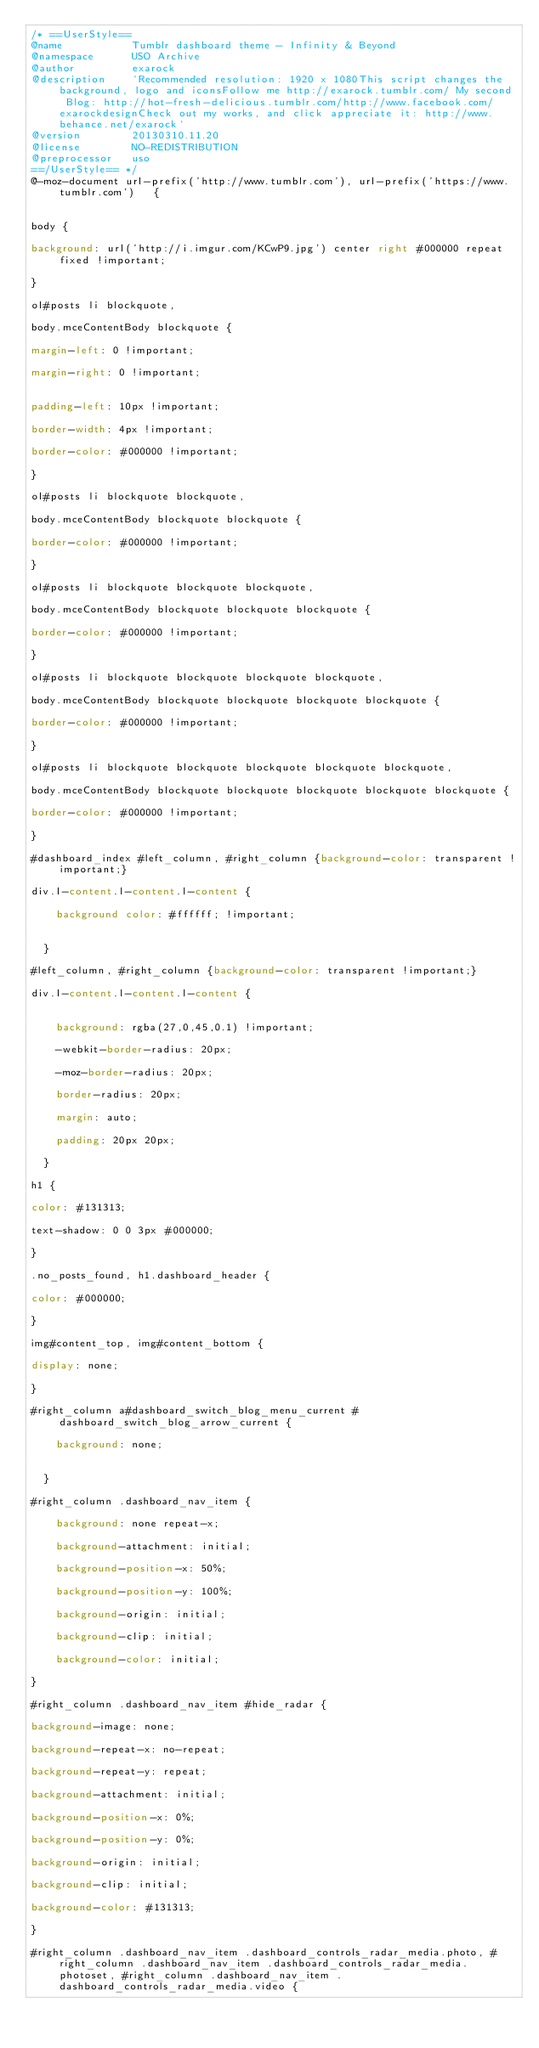Convert code to text. <code><loc_0><loc_0><loc_500><loc_500><_CSS_>/* ==UserStyle==
@name           Tumblr dashboard theme - Infinity & Beyond
@namespace      USO Archive
@author         exarock
@description    `Recommended resolution: 1920 x 1080This script changes the background, logo and iconsFollow me http://exarock.tumblr.com/ My second Blog: http://hot-fresh-delicious.tumblr.com/http://www.facebook.com/exarockdesignCheck out my works, and click appreciate it: http://www.behance.net/exarock`
@version        20130310.11.20
@license        NO-REDISTRIBUTION
@preprocessor   uso
==/UserStyle== */
@-moz-document url-prefix('http://www.tumblr.com'), url-prefix('https://www.tumblr.com')   {


body {

background: url('http://i.imgur.com/KCwP9.jpg') center right #000000 repeat fixed !important;

}

ol#posts li blockquote,

body.mceContentBody blockquote {

margin-left: 0 !important;

margin-right: 0 !important;


padding-left: 10px !important;

border-width: 4px !important;

border-color: #000000 !important;

}

ol#posts li blockquote blockquote,

body.mceContentBody blockquote blockquote {

border-color: #000000 !important;

}

ol#posts li blockquote blockquote blockquote,

body.mceContentBody blockquote blockquote blockquote {

border-color: #000000 !important;

}

ol#posts li blockquote blockquote blockquote blockquote,

body.mceContentBody blockquote blockquote blockquote blockquote {

border-color: #000000 !important;

}

ol#posts li blockquote blockquote blockquote blockquote blockquote,

body.mceContentBody blockquote blockquote blockquote blockquote blockquote {

border-color: #000000 !important;

}

#dashboard_index #left_column, #right_column {background-color: transparent !important;}

div.l-content.l-content.l-content {

    background color: #ffffff; !important;


  }

#left_column, #right_column {background-color: transparent !important;}

div.l-content.l-content.l-content {


    background: rgba(27,0,45,0.1) !important;

    -webkit-border-radius: 20px;

    -moz-border-radius: 20px;

    border-radius: 20px;

    margin: auto;

    padding: 20px 20px;

  }

h1 {

color: #131313;

text-shadow: 0 0 3px #000000;

}

.no_posts_found, h1.dashboard_header {

color: #000000;

}

img#content_top, img#content_bottom {

display: none;

}

#right_column a#dashboard_switch_blog_menu_current #dashboard_switch_blog_arrow_current {

    background: none;


  }

#right_column .dashboard_nav_item {

    background: none repeat-x;

    background-attachment: initial;

    background-position-x: 50%;

    background-position-y: 100%;

    background-origin: initial;

    background-clip: initial;

    background-color: initial;

}

#right_column .dashboard_nav_item #hide_radar {

background-image: none;

background-repeat-x: no-repeat;

background-repeat-y: repeat;

background-attachment: initial;

background-position-x: 0%;

background-position-y: 0%;

background-origin: initial;

background-clip: initial;

background-color: #131313;

}

#right_column .dashboard_nav_item .dashboard_controls_radar_media.photo, #right_column .dashboard_nav_item .dashboard_controls_radar_media.photoset, #right_column .dashboard_nav_item .dashboard_controls_radar_media.video {
</code> 